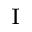Convert formula to latex. <formula><loc_0><loc_0><loc_500><loc_500>_ { I }</formula> 